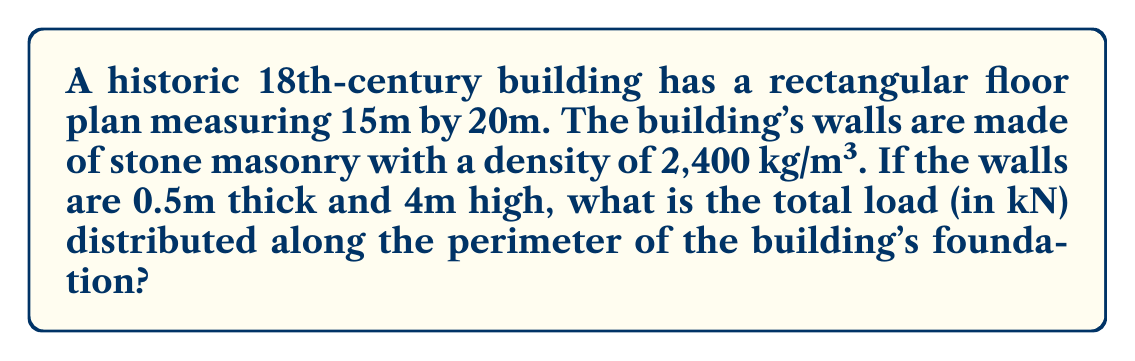Could you help me with this problem? To calculate the total load distributed along the perimeter of the building's foundation, we need to follow these steps:

1. Calculate the perimeter of the building:
   $$P = 2(l + w) = 2(15 + 20) = 70\text{ m}$$

2. Calculate the volume of the walls:
   $$V = P \times h \times t$$
   Where $h$ is the height and $t$ is the thickness
   $$V = 70 \times 4 \times 0.5 = 140\text{ m}^3$$

3. Calculate the mass of the walls:
   $$m = V \times \rho$$
   Where $\rho$ is the density of stone masonry
   $$m = 140 \times 2,400 = 336,000\text{ kg}$$

4. Convert the mass to force (load) using gravity ($g = 9.81\text{ m/s}^2$):
   $$F = m \times g = 336,000 \times 9.81 = 3,296,160\text{ N} = 3,296.16\text{ kN}$$

Therefore, the total load distributed along the perimeter of the building's foundation is 3,296.16 kN.
Answer: 3,296.16 kN 